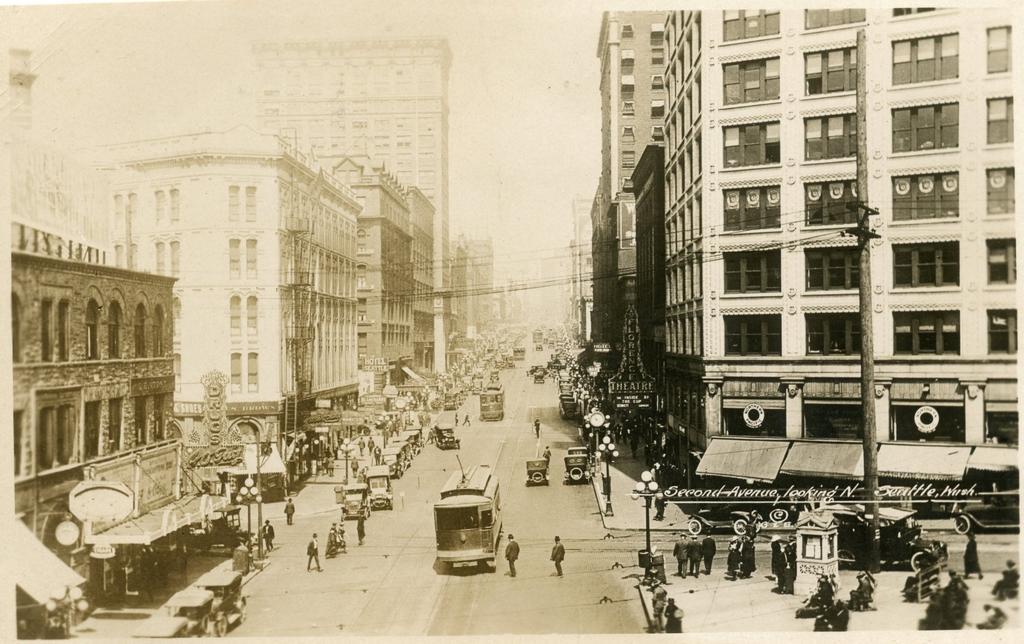How would you summarize this image in a sentence or two? This is a black and white picture. Here we can see buildings, poles, boards, people, and lights. There are vehicles on the road. In the background there is sky. 